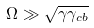<formula> <loc_0><loc_0><loc_500><loc_500>\Omega \gg \sqrt { \gamma \gamma _ { c b } }</formula> 